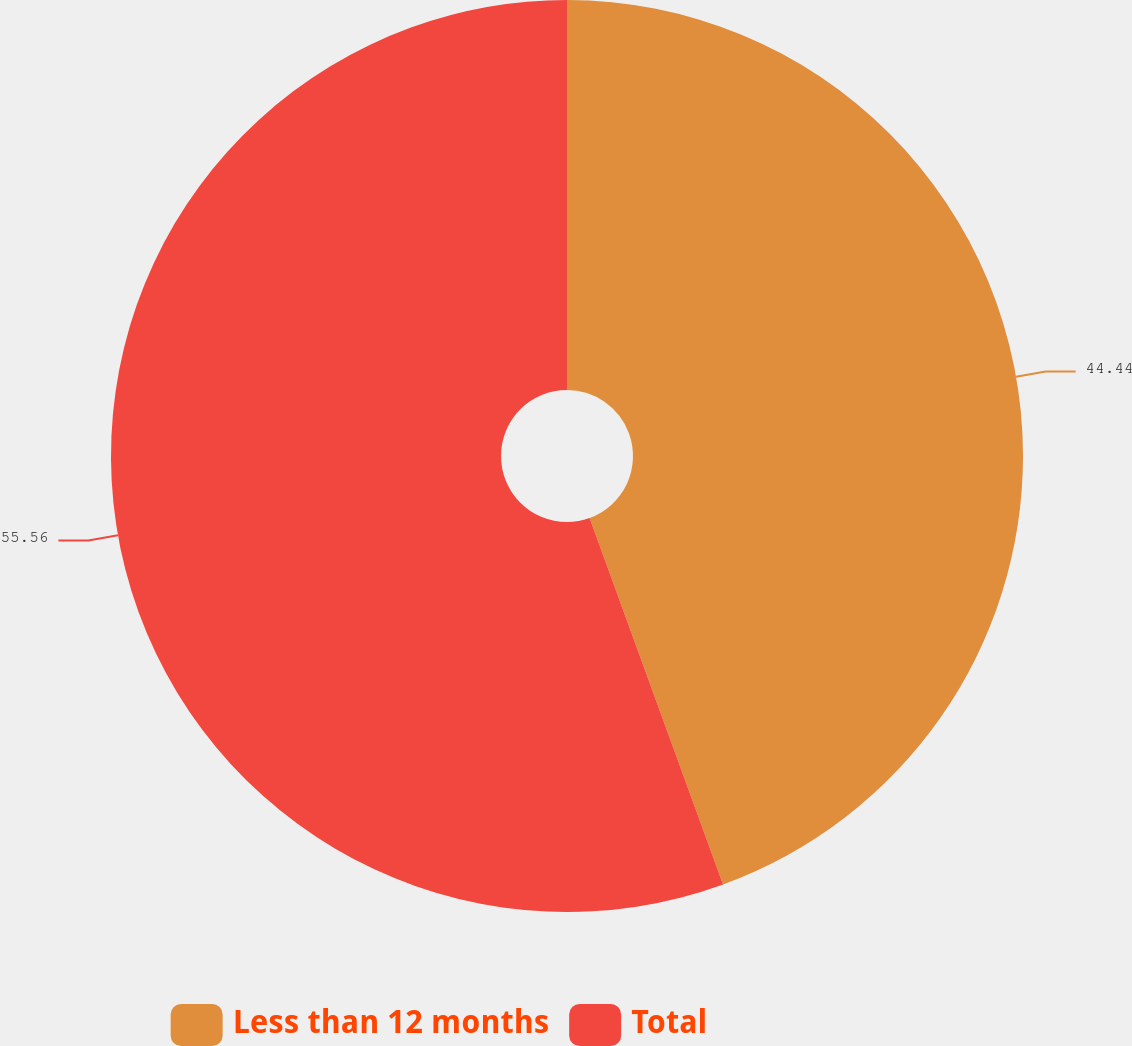<chart> <loc_0><loc_0><loc_500><loc_500><pie_chart><fcel>Less than 12 months<fcel>Total<nl><fcel>44.44%<fcel>55.56%<nl></chart> 